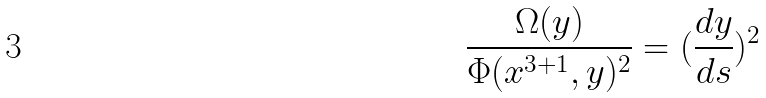Convert formula to latex. <formula><loc_0><loc_0><loc_500><loc_500>\frac { \Omega ( y ) } { \Phi ( x ^ { 3 + 1 } , y ) ^ { 2 } } = ( \frac { d y } { d s } ) ^ { 2 }</formula> 